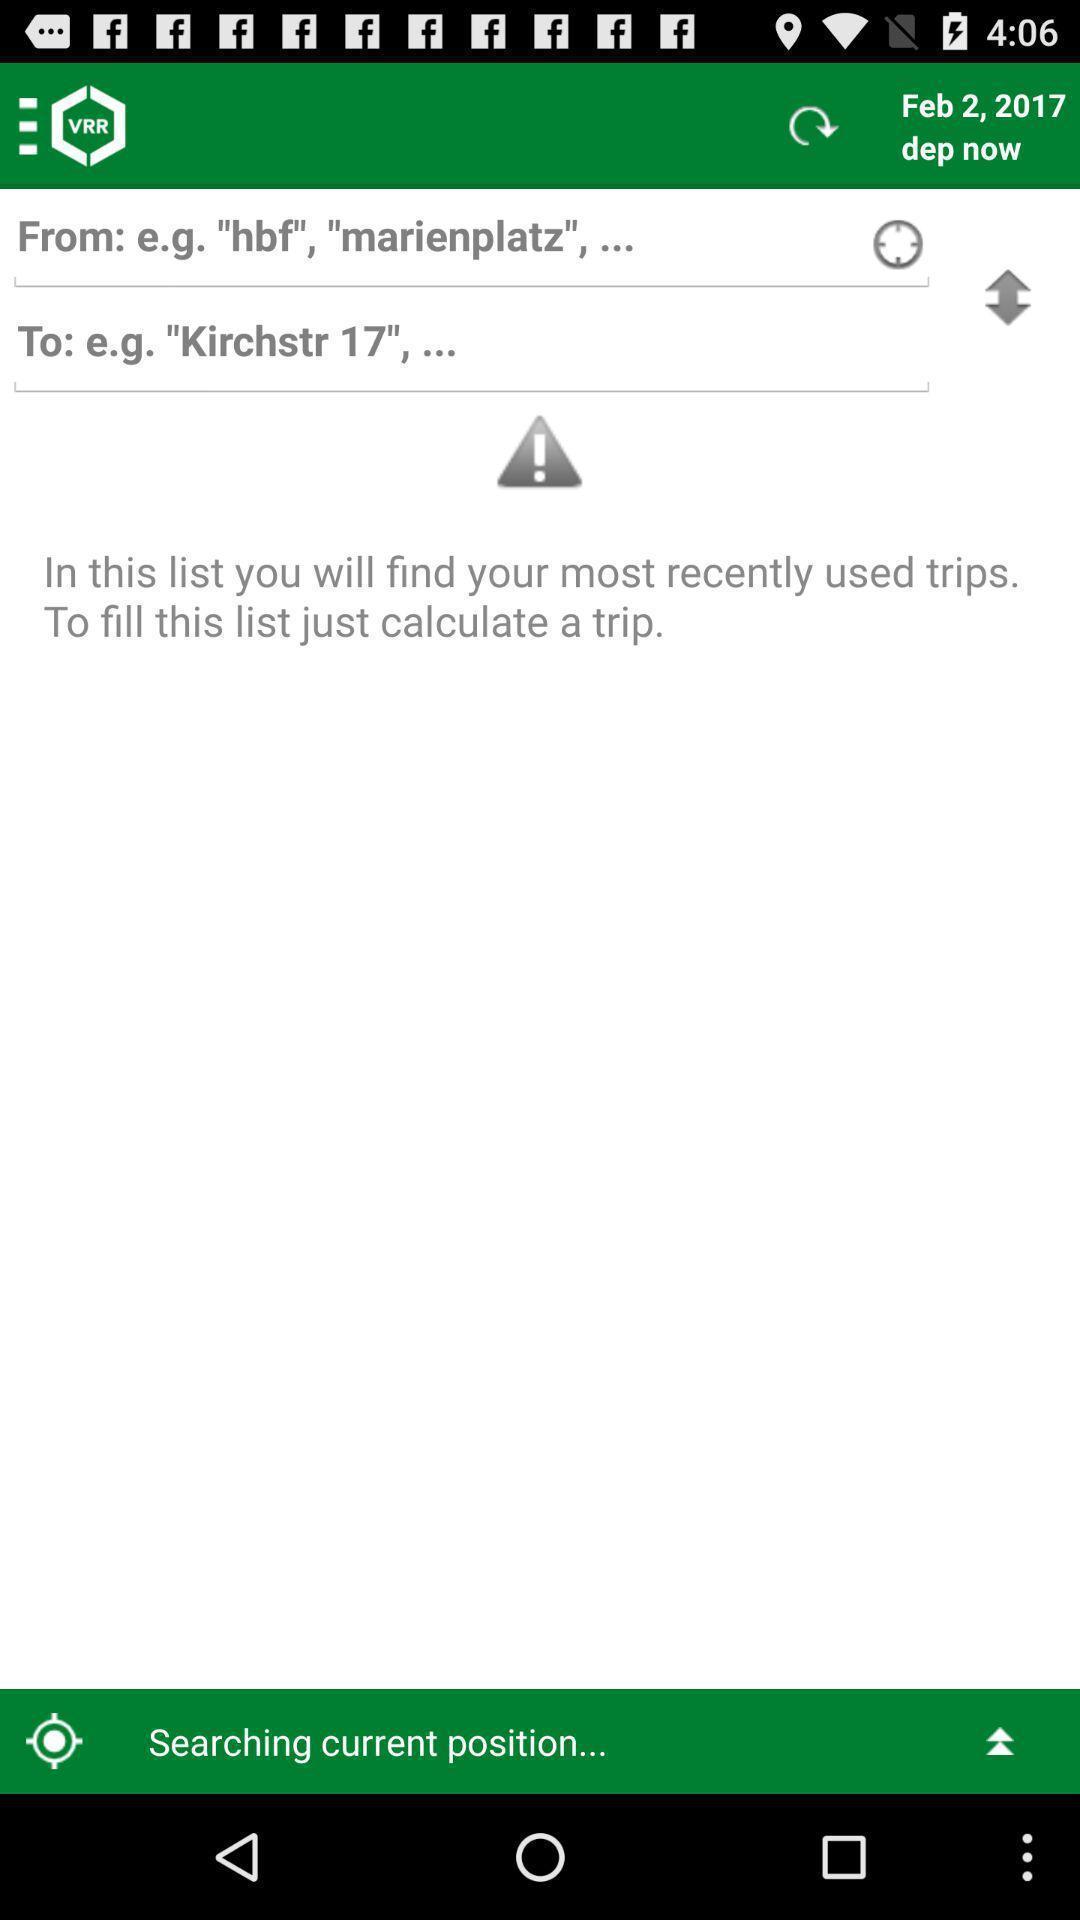Tell me what you see in this picture. Search page displayed of a map navigation app. 